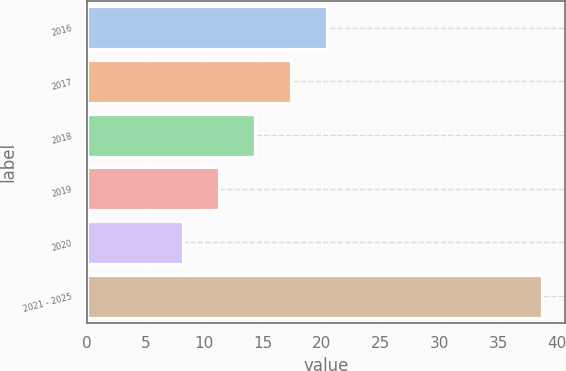<chart> <loc_0><loc_0><loc_500><loc_500><bar_chart><fcel>2016<fcel>2017<fcel>2018<fcel>2019<fcel>2020<fcel>2021 - 2025<nl><fcel>20.4<fcel>17.35<fcel>14.3<fcel>11.25<fcel>8.2<fcel>38.7<nl></chart> 